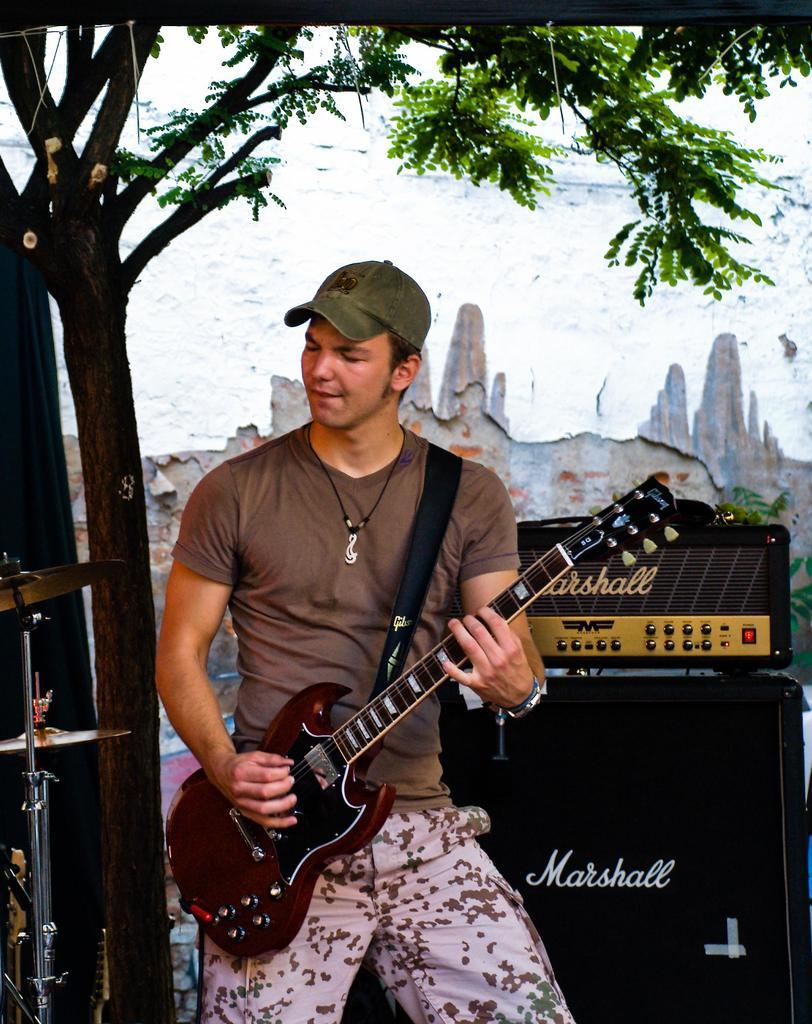What is the person in the image doing? The person in the image is holding a guitar. What object can be seen near the person? There is a speaker in the image. What type of natural element is present in the image? There is a tree in the image. What type of man-made structures are visible in the image? There are buildings in the image. What type of quilt is being used as a prop in the image? There is no quilt present in the image. What type of joke is being told by the person in the image? There is no indication of a joke being told in the image. 